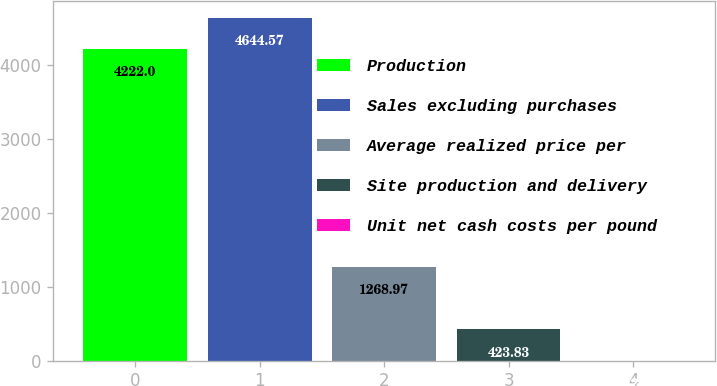Convert chart to OTSL. <chart><loc_0><loc_0><loc_500><loc_500><bar_chart><fcel>Production<fcel>Sales excluding purchases<fcel>Average realized price per<fcel>Site production and delivery<fcel>Unit net cash costs per pound<nl><fcel>4222<fcel>4644.57<fcel>1268.97<fcel>423.83<fcel>1.26<nl></chart> 